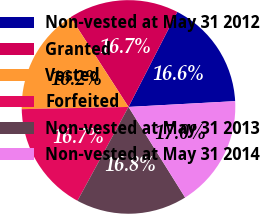Convert chart to OTSL. <chart><loc_0><loc_0><loc_500><loc_500><pie_chart><fcel>Non-vested at May 31 2012<fcel>Granted<fcel>Vested<fcel>Forfeited<fcel>Non-vested at May 31 2013<fcel>Non-vested at May 31 2014<nl><fcel>16.59%<fcel>16.67%<fcel>16.21%<fcel>16.74%<fcel>16.82%<fcel>16.97%<nl></chart> 